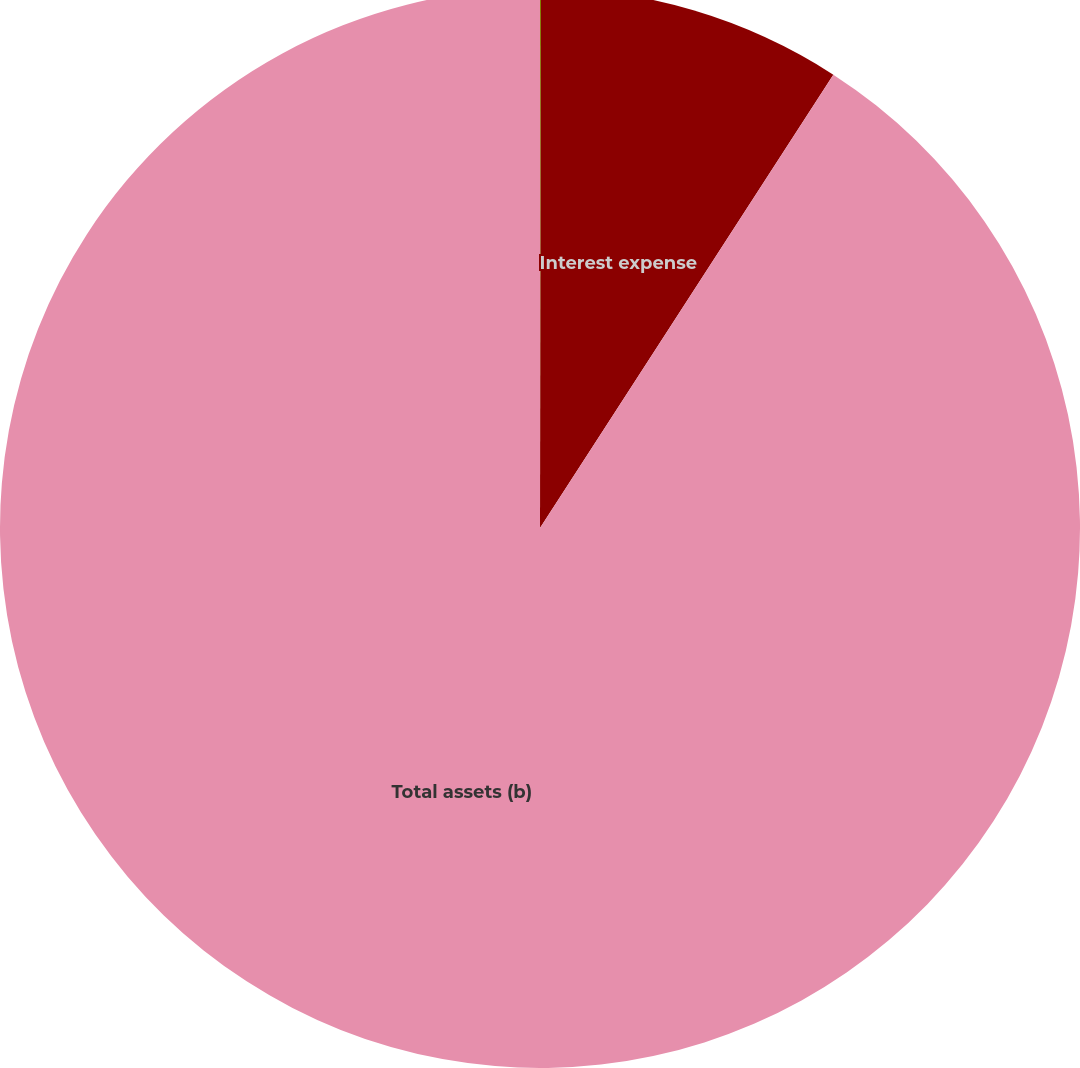Convert chart to OTSL. <chart><loc_0><loc_0><loc_500><loc_500><pie_chart><fcel>Interest and dividend income<fcel>Interest expense<fcel>Total assets (b)<nl><fcel>0.03%<fcel>9.11%<fcel>90.86%<nl></chart> 